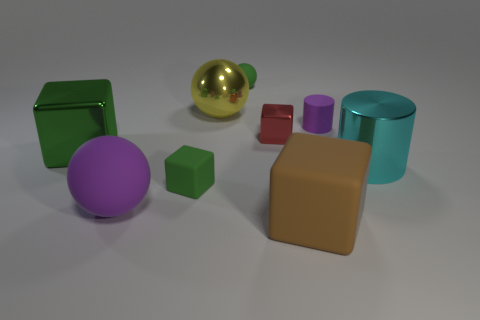Subtract all large balls. How many balls are left? 1 Subtract all yellow cylinders. How many green blocks are left? 2 Add 1 cyan metal things. How many objects exist? 10 Subtract all cubes. How many objects are left? 5 Subtract all red cubes. How many cubes are left? 3 Subtract 0 cyan spheres. How many objects are left? 9 Subtract all blue balls. Subtract all brown blocks. How many balls are left? 3 Subtract all large yellow metallic things. Subtract all big cyan metallic objects. How many objects are left? 7 Add 4 brown matte objects. How many brown matte objects are left? 5 Add 9 green matte balls. How many green matte balls exist? 10 